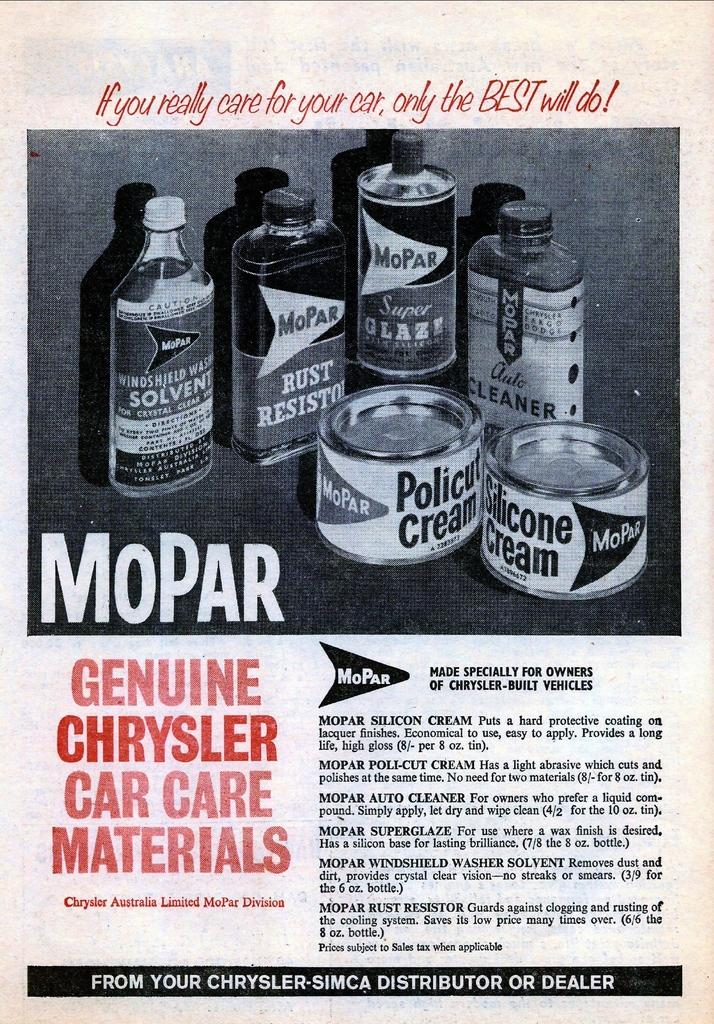<image>
Render a clear and concise summary of the photo. An advertisement for MoPar genuine Chrysler car care materials. 